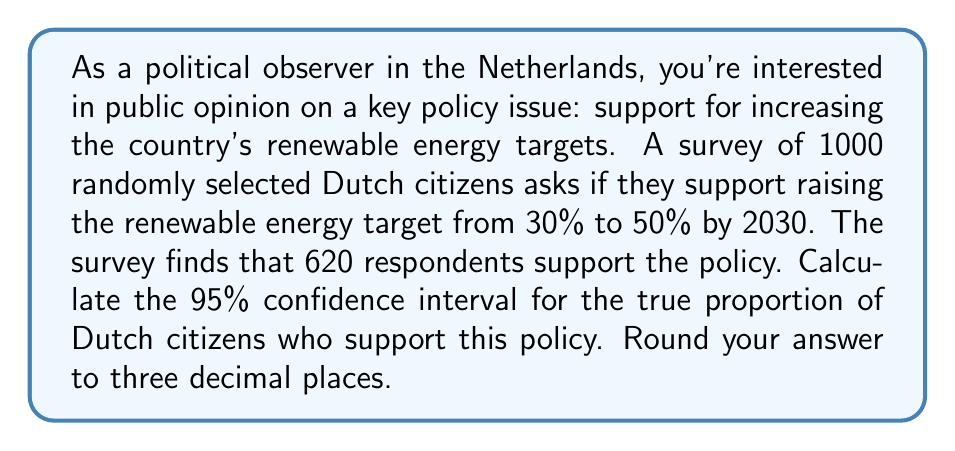Show me your answer to this math problem. To calculate the confidence interval, we'll use the formula for the margin of error in a proportion:

$$ \text{Margin of Error} = z \sqrt{\frac{p(1-p)}{n}} $$

Where:
- $z$ is the z-score for the desired confidence level (1.96 for 95% confidence)
- $p$ is the sample proportion
- $n$ is the sample size

Step 1: Calculate the sample proportion $(p)$
$p = \frac{620}{1000} = 0.62$

Step 2: Calculate the standard error
$$ SE = \sqrt{\frac{p(1-p)}{n}} = \sqrt{\frac{0.62(1-0.62)}{1000}} = \sqrt{\frac{0.2356}{1000}} = 0.0153 $$

Step 3: Calculate the margin of error
$$ \text{Margin of Error} = 1.96 \times 0.0153 = 0.0300 $$

Step 4: Calculate the confidence interval
Lower bound: $0.62 - 0.0300 = 0.5900$
Upper bound: $0.62 + 0.0300 = 0.6500$

Therefore, we can be 95% confident that the true proportion of Dutch citizens who support increasing the renewable energy target falls between 0.590 and 0.650, or between 59.0% and 65.0%.
Answer: The 95% confidence interval is (0.590, 0.650) or (59.0%, 65.0%). 